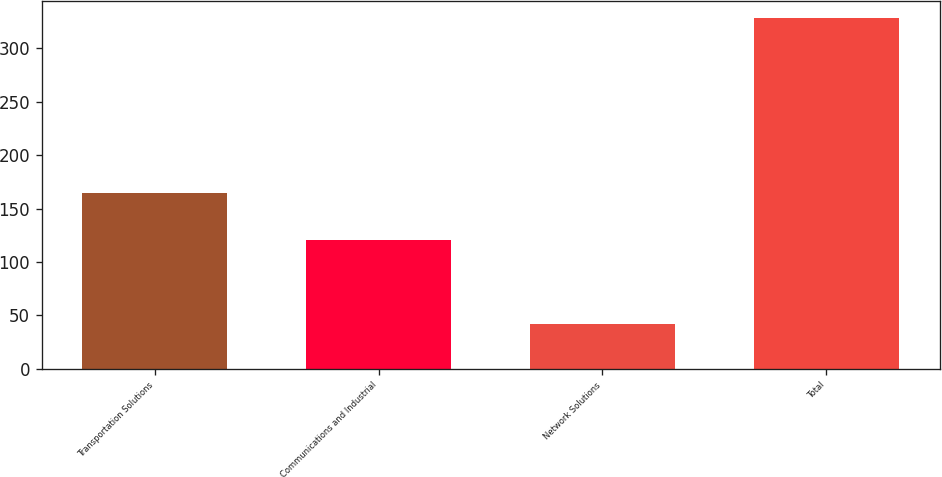Convert chart. <chart><loc_0><loc_0><loc_500><loc_500><bar_chart><fcel>Transportation Solutions<fcel>Communications and Industrial<fcel>Network Solutions<fcel>Total<nl><fcel>165<fcel>121<fcel>42<fcel>328<nl></chart> 